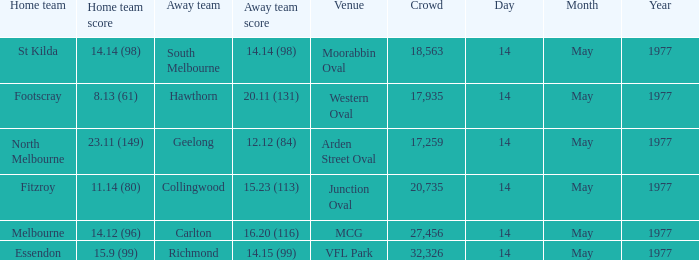How many individuals were present in the crowd when the visiting team was collingwood? 1.0. 